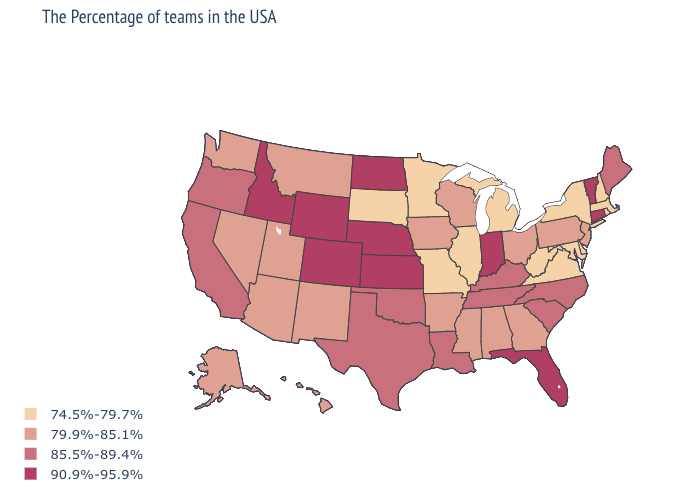Which states have the lowest value in the USA?
Concise answer only. Massachusetts, Rhode Island, New Hampshire, New York, Delaware, Maryland, Virginia, West Virginia, Michigan, Illinois, Missouri, Minnesota, South Dakota. Does the first symbol in the legend represent the smallest category?
Give a very brief answer. Yes. Name the states that have a value in the range 85.5%-89.4%?
Short answer required. Maine, North Carolina, South Carolina, Kentucky, Tennessee, Louisiana, Oklahoma, Texas, California, Oregon. Name the states that have a value in the range 74.5%-79.7%?
Be succinct. Massachusetts, Rhode Island, New Hampshire, New York, Delaware, Maryland, Virginia, West Virginia, Michigan, Illinois, Missouri, Minnesota, South Dakota. Name the states that have a value in the range 79.9%-85.1%?
Give a very brief answer. New Jersey, Pennsylvania, Ohio, Georgia, Alabama, Wisconsin, Mississippi, Arkansas, Iowa, New Mexico, Utah, Montana, Arizona, Nevada, Washington, Alaska, Hawaii. Name the states that have a value in the range 74.5%-79.7%?
Give a very brief answer. Massachusetts, Rhode Island, New Hampshire, New York, Delaware, Maryland, Virginia, West Virginia, Michigan, Illinois, Missouri, Minnesota, South Dakota. Does Kansas have the highest value in the MidWest?
Concise answer only. Yes. What is the value of Idaho?
Quick response, please. 90.9%-95.9%. Which states have the lowest value in the South?
Write a very short answer. Delaware, Maryland, Virginia, West Virginia. What is the value of Arizona?
Concise answer only. 79.9%-85.1%. Does North Dakota have the highest value in the USA?
Quick response, please. Yes. Does the first symbol in the legend represent the smallest category?
Give a very brief answer. Yes. Name the states that have a value in the range 90.9%-95.9%?
Concise answer only. Vermont, Connecticut, Florida, Indiana, Kansas, Nebraska, North Dakota, Wyoming, Colorado, Idaho. Does the map have missing data?
Quick response, please. No. What is the value of Rhode Island?
Keep it brief. 74.5%-79.7%. 